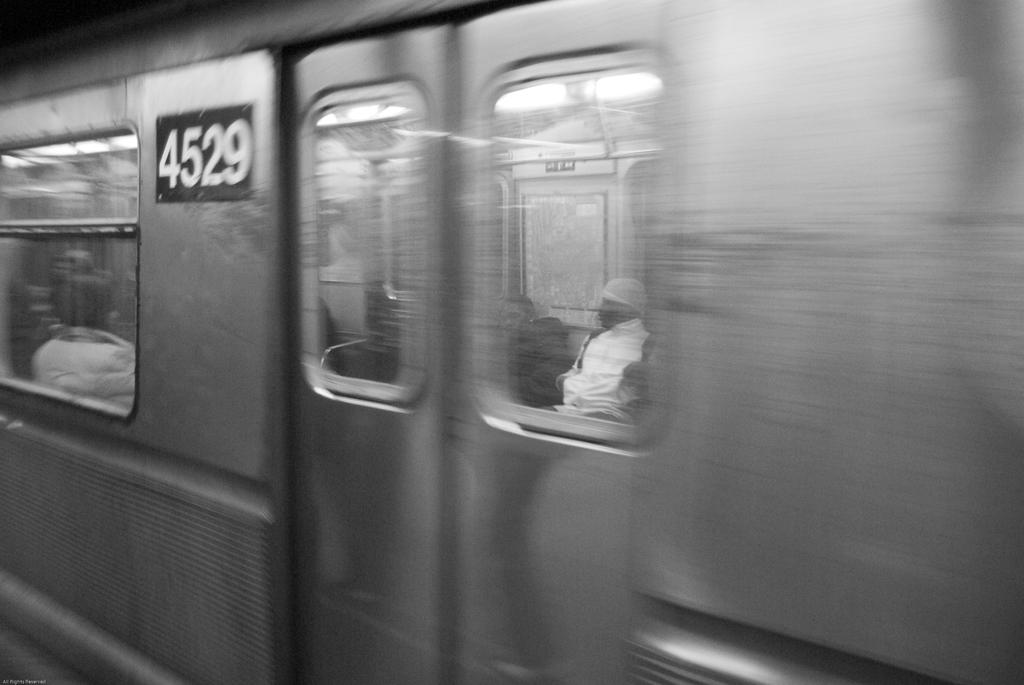<image>
Summarize the visual content of the image. Silver subway car number 4529 traveling with passengers in the car. 